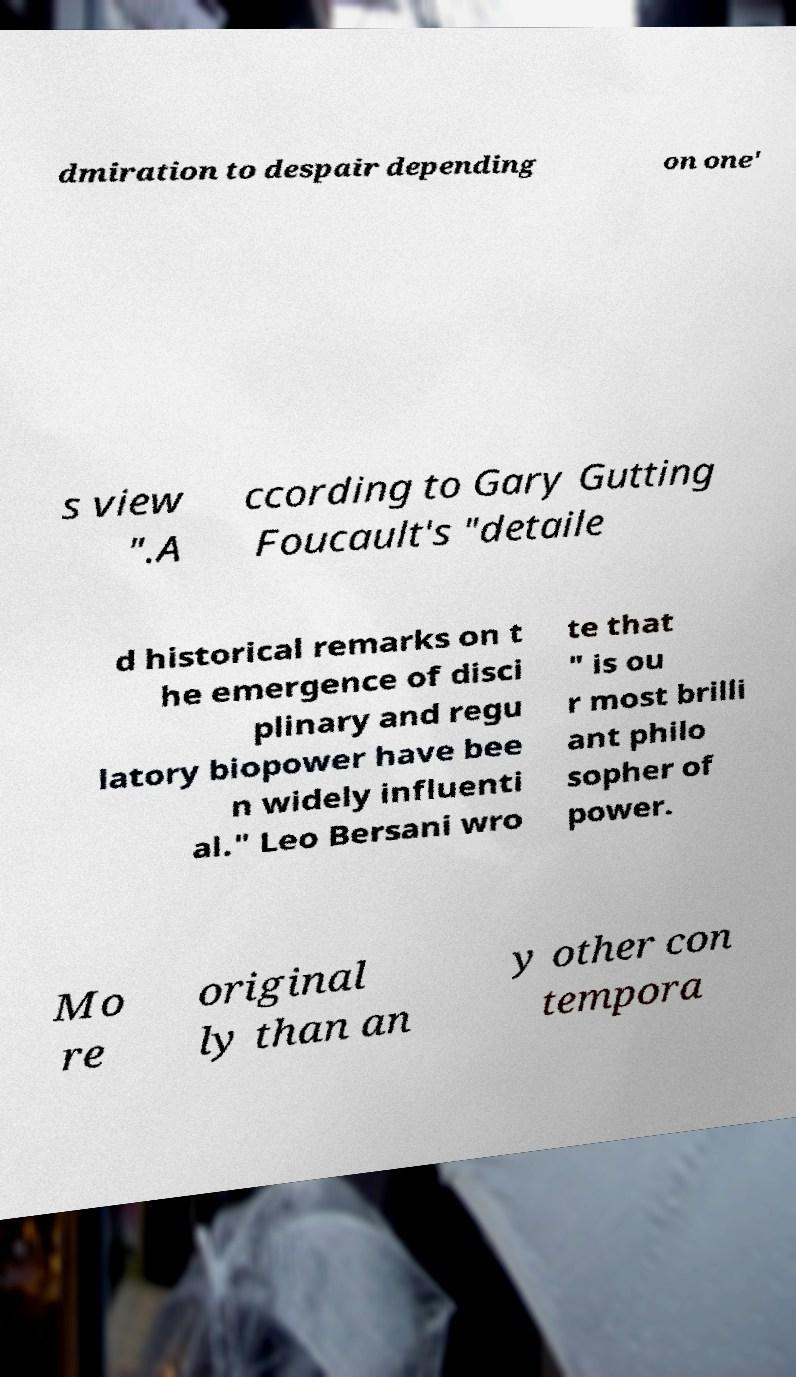Please read and relay the text visible in this image. What does it say? dmiration to despair depending on one' s view ".A ccording to Gary Gutting Foucault's "detaile d historical remarks on t he emergence of disci plinary and regu latory biopower have bee n widely influenti al." Leo Bersani wro te that " is ou r most brilli ant philo sopher of power. Mo re original ly than an y other con tempora 